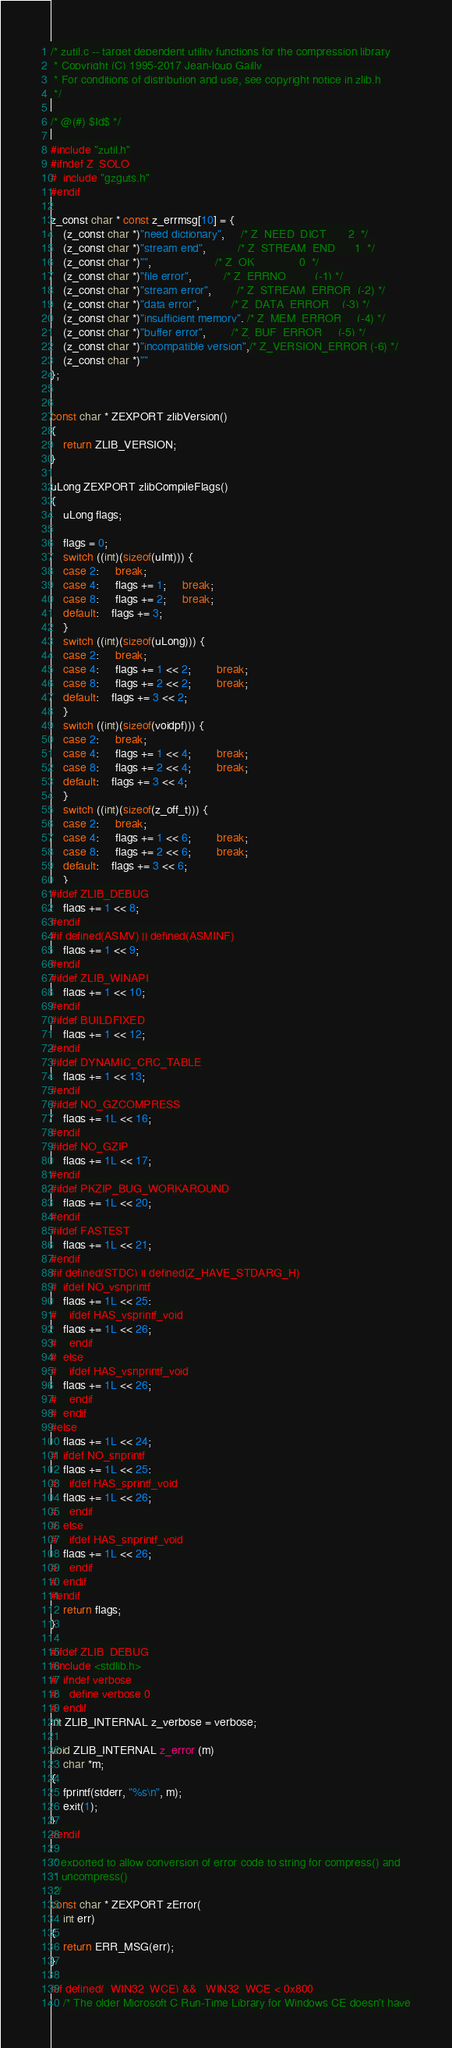Convert code to text. <code><loc_0><loc_0><loc_500><loc_500><_C_>/* zutil.c -- target dependent utility functions for the compression library
 * Copyright (C) 1995-2017 Jean-loup Gailly
 * For conditions of distribution and use, see copyright notice in zlib.h
 */

/* @(#) $Id$ */

#include "zutil.h"
#ifndef Z_SOLO
#  include "gzguts.h"
#endif

z_const char * const z_errmsg[10] = {
    (z_const char *)"need dictionary",     /* Z_NEED_DICT       2  */
    (z_const char *)"stream end",          /* Z_STREAM_END      1  */
    (z_const char *)"",                    /* Z_OK              0  */
    (z_const char *)"file error",          /* Z_ERRNO         (-1) */
    (z_const char *)"stream error",        /* Z_STREAM_ERROR  (-2) */
    (z_const char *)"data error",          /* Z_DATA_ERROR    (-3) */
    (z_const char *)"insufficient memory", /* Z_MEM_ERROR     (-4) */
    (z_const char *)"buffer error",        /* Z_BUF_ERROR     (-5) */
    (z_const char *)"incompatible version",/* Z_VERSION_ERROR (-6) */
    (z_const char *)""
};


const char * ZEXPORT zlibVersion()
{
    return ZLIB_VERSION;
}

uLong ZEXPORT zlibCompileFlags()
{
    uLong flags;

    flags = 0;
    switch ((int)(sizeof(uInt))) {
    case 2:     break;
    case 4:     flags += 1;     break;
    case 8:     flags += 2;     break;
    default:    flags += 3;
    }
    switch ((int)(sizeof(uLong))) {
    case 2:     break;
    case 4:     flags += 1 << 2;        break;
    case 8:     flags += 2 << 2;        break;
    default:    flags += 3 << 2;
    }
    switch ((int)(sizeof(voidpf))) {
    case 2:     break;
    case 4:     flags += 1 << 4;        break;
    case 8:     flags += 2 << 4;        break;
    default:    flags += 3 << 4;
    }
    switch ((int)(sizeof(z_off_t))) {
    case 2:     break;
    case 4:     flags += 1 << 6;        break;
    case 8:     flags += 2 << 6;        break;
    default:    flags += 3 << 6;
    }
#ifdef ZLIB_DEBUG
    flags += 1 << 8;
#endif
#if defined(ASMV) || defined(ASMINF)
    flags += 1 << 9;
#endif
#ifdef ZLIB_WINAPI
    flags += 1 << 10;
#endif
#ifdef BUILDFIXED
    flags += 1 << 12;
#endif
#ifdef DYNAMIC_CRC_TABLE
    flags += 1 << 13;
#endif
#ifdef NO_GZCOMPRESS
    flags += 1L << 16;
#endif
#ifdef NO_GZIP
    flags += 1L << 17;
#endif
#ifdef PKZIP_BUG_WORKAROUND
    flags += 1L << 20;
#endif
#ifdef FASTEST
    flags += 1L << 21;
#endif
#if defined(STDC) || defined(Z_HAVE_STDARG_H)
#  ifdef NO_vsnprintf
    flags += 1L << 25;
#    ifdef HAS_vsprintf_void
    flags += 1L << 26;
#    endif
#  else
#    ifdef HAS_vsnprintf_void
    flags += 1L << 26;
#    endif
#  endif
#else
    flags += 1L << 24;
#  ifdef NO_snprintf
    flags += 1L << 25;
#    ifdef HAS_sprintf_void
    flags += 1L << 26;
#    endif
#  else
#    ifdef HAS_snprintf_void
    flags += 1L << 26;
#    endif
#  endif
#endif
    return flags;
}

#ifdef ZLIB_DEBUG
#include <stdlib.h>
#  ifndef verbose
#    define verbose 0
#  endif
int ZLIB_INTERNAL z_verbose = verbose;

void ZLIB_INTERNAL z_error (m)
    char *m;
{
    fprintf(stderr, "%s\n", m);
    exit(1);
}
#endif

/* exported to allow conversion of error code to string for compress() and
 * uncompress()
 */
const char * ZEXPORT zError(
    int err)
{
    return ERR_MSG(err);
}

#if defined(_WIN32_WCE) && _WIN32_WCE < 0x800
    /* The older Microsoft C Run-Time Library for Windows CE doesn't have</code> 